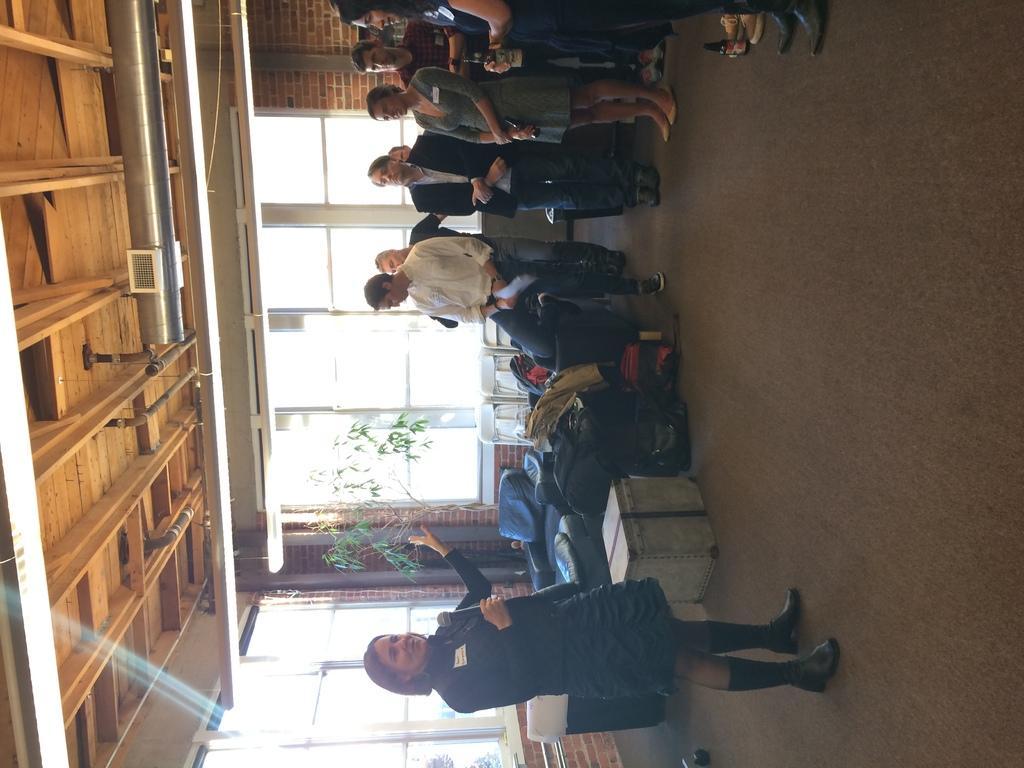How would you summarize this image in a sentence or two? In the center of the image we can see a few people are standing and they are in different costumes. Among them, we can see a few people are holding some objects. In the background there is a brick wall, plant with branches and leaves, glass, bags and a few other objects. 